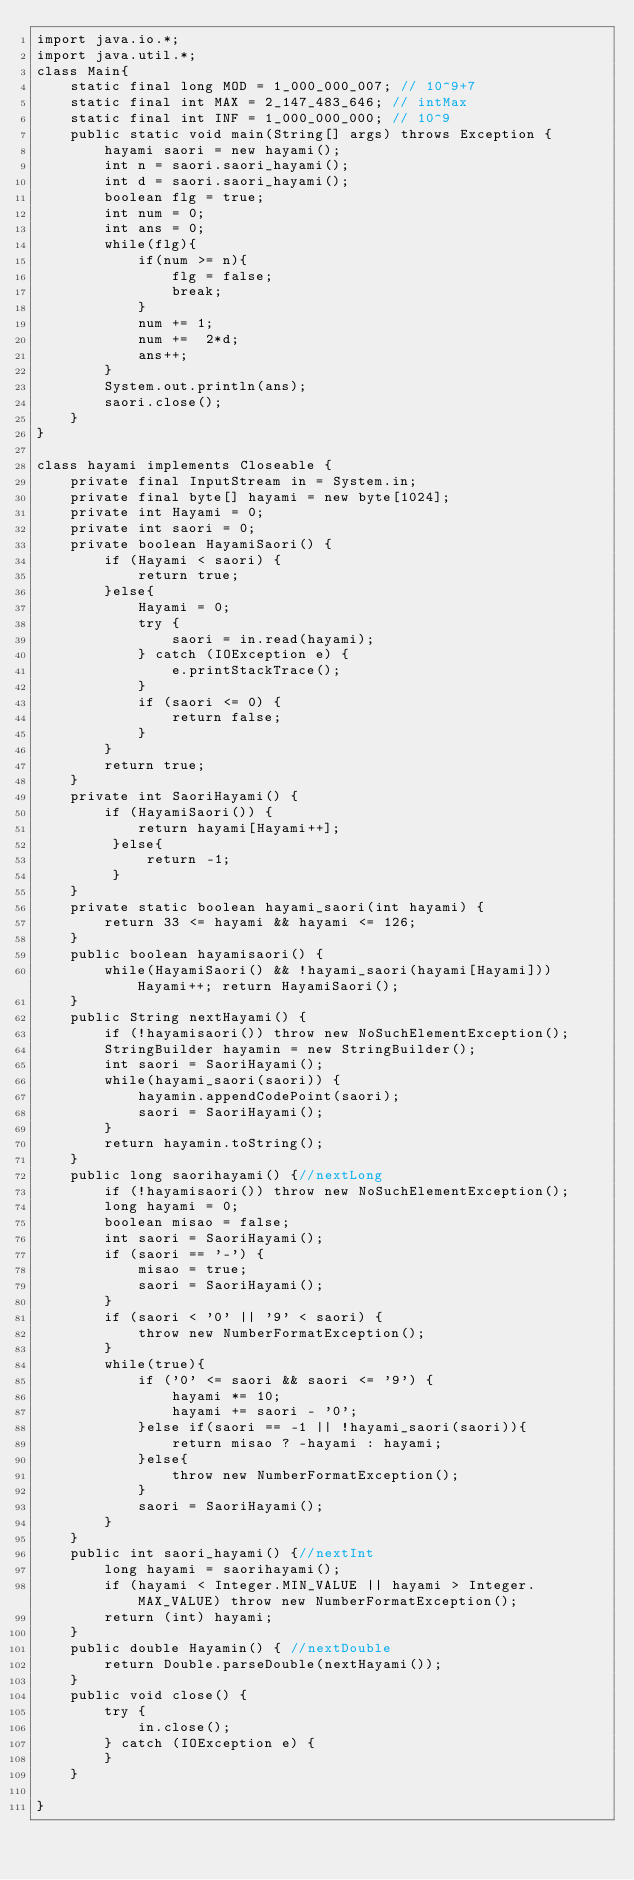Convert code to text. <code><loc_0><loc_0><loc_500><loc_500><_Java_>import java.io.*;
import java.util.*;
class Main{
	static final long MOD = 1_000_000_007; // 10^9+7
    static final int MAX = 2_147_483_646; // intMax 
    static final int INF = 1_000_000_000; // 10^9  
    public static void main(String[] args) throws Exception {
		hayami saori = new hayami();
		int n = saori.saori_hayami();
		int d = saori.saori_hayami();
		boolean flg = true;
		int num = 0;
		int ans = 0;
		while(flg){
			if(num >= n){
				flg = false;
				break;
			}
			num += 1;
			num +=  2*d;
			ans++;
		}
		System.out.println(ans);
		saori.close();
    }
}

class hayami implements Closeable {
	private final InputStream in = System.in;
	private final byte[] hayami = new byte[1024];
	private int Hayami = 0;
	private int saori = 0;
	private boolean HayamiSaori() {
		if (Hayami < saori) {
			return true;
		}else{
			Hayami = 0;
			try {
				saori = in.read(hayami);
			} catch (IOException e) {
				e.printStackTrace();
			}
			if (saori <= 0) {
				return false;
			}
		}
		return true;
	}
	private int SaoriHayami() { 
		if (HayamiSaori()) {
            return hayami[Hayami++];
         }else{
             return -1;
         }
	}
	private static boolean hayami_saori(int hayami) { 
		return 33 <= hayami && hayami <= 126;
	}
	public boolean hayamisaori() { 
		while(HayamiSaori() && !hayami_saori(hayami[Hayami])) Hayami++; return HayamiSaori();
	}
	public String nextHayami() {
		if (!hayamisaori()) throw new NoSuchElementException();
		StringBuilder hayamin = new StringBuilder();
		int saori = SaoriHayami();
		while(hayami_saori(saori)) {
			hayamin.appendCodePoint(saori);
			saori = SaoriHayami();
		}
		return hayamin.toString();
	}
	public long saorihayami() {//nextLong
		if (!hayamisaori()) throw new NoSuchElementException();
		long hayami = 0;
		boolean misao = false;
		int saori = SaoriHayami();
		if (saori == '-') {
			misao = true;
			saori = SaoriHayami();
		}
		if (saori < '0' || '9' < saori) {
			throw new NumberFormatException();
		}
		while(true){
			if ('0' <= saori && saori <= '9') {
				hayami *= 10;
				hayami += saori - '0';
			}else if(saori == -1 || !hayami_saori(saori)){
				return misao ? -hayami : hayami;
			}else{
				throw new NumberFormatException();
			}
			saori = SaoriHayami();
		}
	}
	public int saori_hayami() {//nextInt
		long hayami = saorihayami();
		if (hayami < Integer.MIN_VALUE || hayami > Integer.MAX_VALUE) throw new NumberFormatException();
		return (int) hayami;
	}
	public double Hayamin() { //nextDouble
		return Double.parseDouble(nextHayami());
	}
	public void close() {
		try {
			in.close();
		} catch (IOException e) {
		}
    }
    
}</code> 